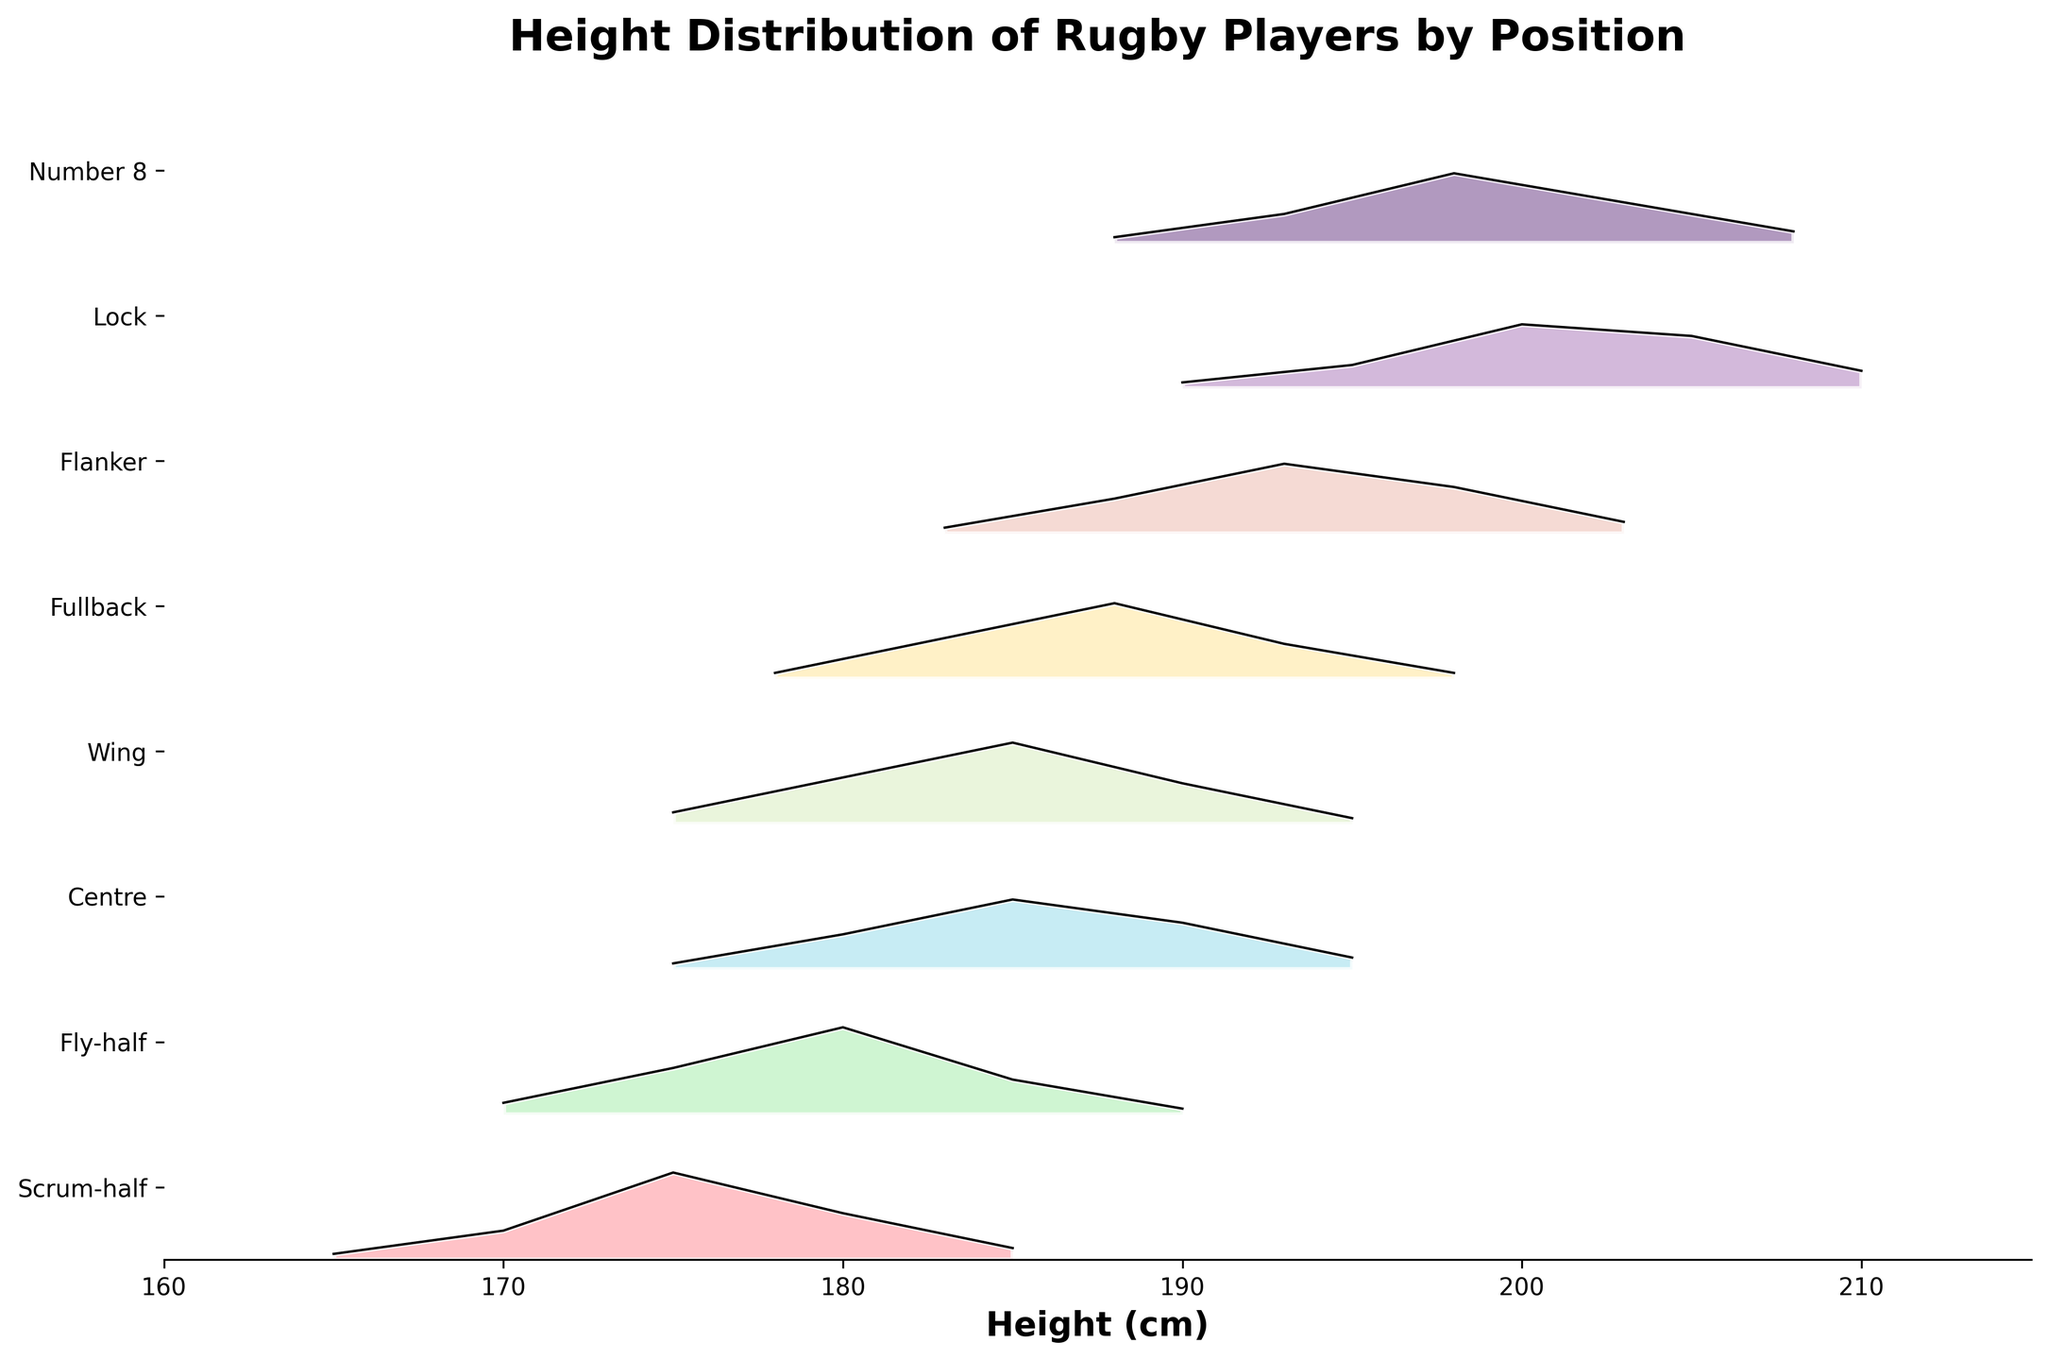What's the title of the plot? The title is usually written at the top of the plot and summarizes the main topic of the figure. In this case, it should describe the main focus of the data presented.
Answer: Height Distribution of Rugby Players by Position How many different rugby positions are included in the plot? The number of different categories or groups in the y-axis represents the distinct rugby positions included in the data. Count the unique labels on the y-axis.
Answer: 7 What is the height range shown on the x-axis? The x-axis usually represents the variable of interest in the plot, which in this case is height. By observing the minimum and maximum values on the x-axis, you can determine the range it covers.
Answer: 160 to 215 cm Which position has the tallest peak in terms of height density? Look along the ridgeline for each position and find the one that reaches the highest point vertically, indicating the highest density.
Answer: Fly-half (185 cm) Which rugby position spans the widest range of heights? Observe each distribution and compare the widths by looking at the minimum and maximum heights covered. The position with the broadest spread represents the widest range.
Answer: Lock (190 to 210 cm) How do the median heights of Fullback and Centre compare? To estimate the median, look for the height around the middle of the densest part of the curve (usually the highest peak) for each position, then compare these median points.
Answer: Fullback's median height is slightly higher than Centre's Which rugby position has the shortest average height? Examine the distributions and determine which curve is generally centered around the lowest height values.
Answer: Scrum-half Are there any rugby positions that do not overlap in height distribution with others? Check the ridgeline plots for any group whose range does not intersect with any other group's range.
Answer: None overlap completely without intersection What's the most common height for the Wing position? Identify the height where the peak of the Wing's distribution curve occurs, as the highest density suggests the most common height.
Answer: 185 cm Which position has the largest spread in density values? Observe the height of the peaks for each position, and identify which position has the most variation in the height of its peaks (i.e., the tallest peak minus the shortest peak within the same position).
Answer: Lock 